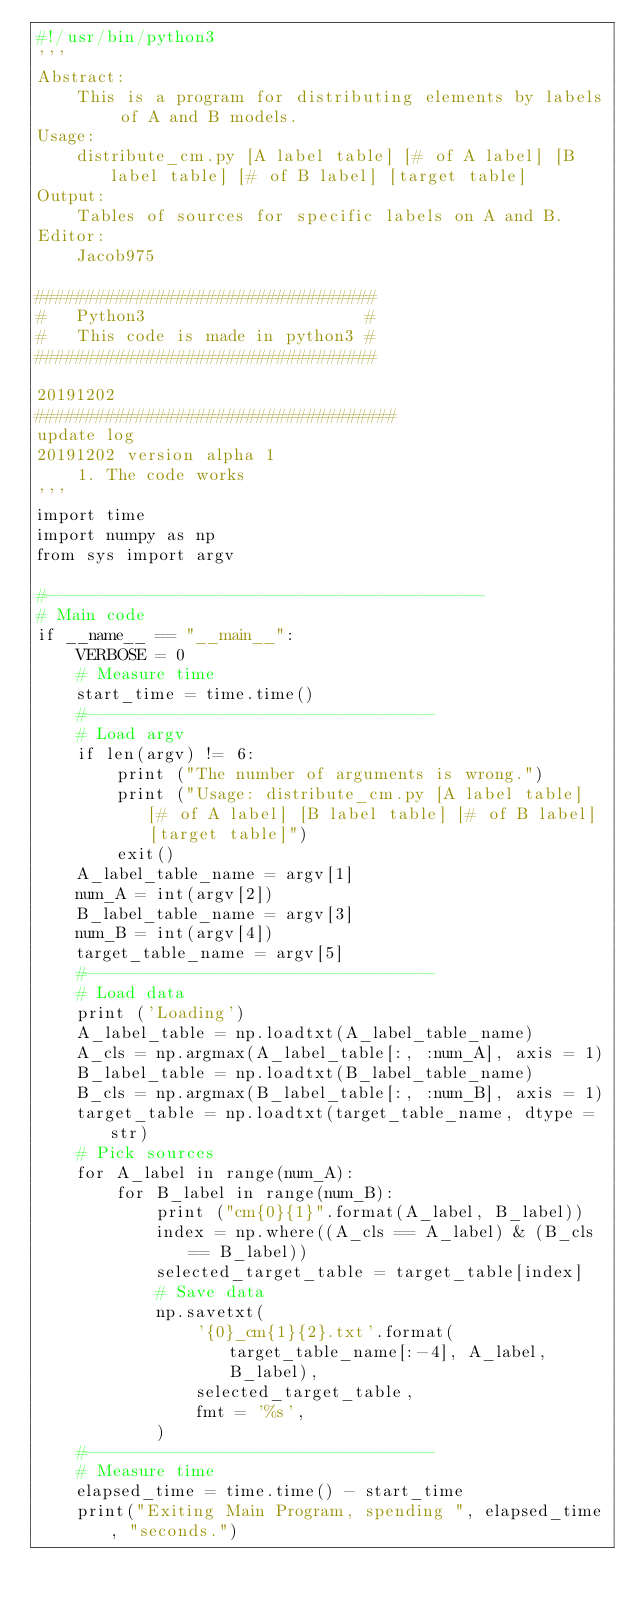<code> <loc_0><loc_0><loc_500><loc_500><_Python_>#!/usr/bin/python3
'''
Abstract:
    This is a program for distributing elements by labels of A and B models. 
Usage:
    distribute_cm.py [A label table] [# of A label] [B label table] [# of B label] [target table]
Output:
    Tables of sources for specific labels on A and B.
Editor:
    Jacob975

##################################
#   Python3                      #
#   This code is made in python3 #
##################################

20191202
####################################
update log
20191202 version alpha 1
    1. The code works
'''
import time
import numpy as np
from sys import argv

#--------------------------------------------
# Main code
if __name__ == "__main__":
    VERBOSE = 0
    # Measure time
    start_time = time.time()
    #-----------------------------------
    # Load argv
    if len(argv) != 6:
        print ("The number of arguments is wrong.")
        print ("Usage: distribute_cm.py [A label table] [# of A label] [B label table] [# of B label] [target table]") 
        exit()
    A_label_table_name = argv[1]
    num_A = int(argv[2])
    B_label_table_name = argv[3]
    num_B = int(argv[4])
    target_table_name = argv[5]
    #-----------------------------------
    # Load data
    print ('Loading')
    A_label_table = np.loadtxt(A_label_table_name)
    A_cls = np.argmax(A_label_table[:, :num_A], axis = 1)
    B_label_table = np.loadtxt(B_label_table_name)
    B_cls = np.argmax(B_label_table[:, :num_B], axis = 1)
    target_table = np.loadtxt(target_table_name, dtype = str)
    # Pick sources
    for A_label in range(num_A):
        for B_label in range(num_B):
            print ("cm{0}{1}".format(A_label, B_label))
            index = np.where((A_cls == A_label) & (B_cls == B_label))
            selected_target_table = target_table[index]
            # Save data
            np.savetxt(
                '{0}_cm{1}{2}.txt'.format(target_table_name[:-4], A_label, B_label),
                selected_target_table,
                fmt = '%s',
            )
    #-----------------------------------
    # Measure time
    elapsed_time = time.time() - start_time
    print("Exiting Main Program, spending ", elapsed_time, "seconds.")
</code> 